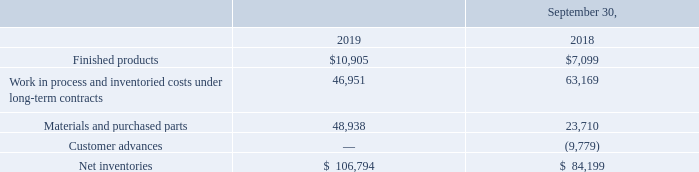NOTE 8—INVENTORIES
Inventories consist of the following (in thousands):
At September 30, 2019, work in process and inventoried costs under long-term contracts includes approximately $5.8 million in costs incurred outside the scope of work or in advance of a contract award compared to $0.9 million at September 30, 2018. We believe it is probable that we will recover the costs inventoried at September 30, 2019, plus a profit margin, under contract change orders or awards within the next year.
Costs we incur for certain U.S. federal government contracts include general and administrative costs as allowed by government cost accounting standards. The amounts remaining in inventory at September 30, 2019 and 2018 were $0.5 million and $2.0 million, respectively.
What is the amount of finished products in 2019?
Answer scale should be: thousand. $10,905. What do the costs incurred for certain U.S. federal government contracts include? General and administrative costs as allowed by government cost accounting standards. What are the components that make up the net inventories? Finished products, work in process and inventoried costs under long-term contracts, materials and purchased parts, customer advances. In which year is the value of finished products higher? 10,905>7,099
Answer: 2019. What is the change in materials and purchased parts from 2018 to 2019?
Answer scale should be: thousand. 48,938-23,710
Answer: 25228. What is the percentage change in net inventories from 2018 to 2019?
Answer scale should be: percent. (106,794-84,199)/84,199
Answer: 26.84. 